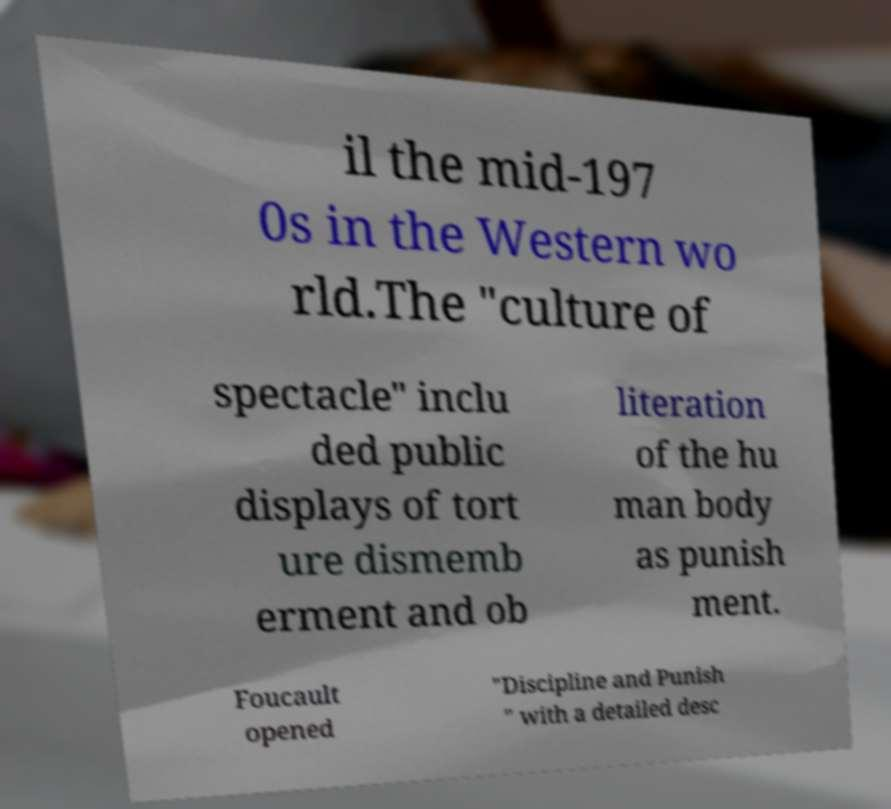I need the written content from this picture converted into text. Can you do that? il the mid-197 0s in the Western wo rld.The "culture of spectacle" inclu ded public displays of tort ure dismemb erment and ob literation of the hu man body as punish ment. Foucault opened "Discipline and Punish " with a detailed desc 